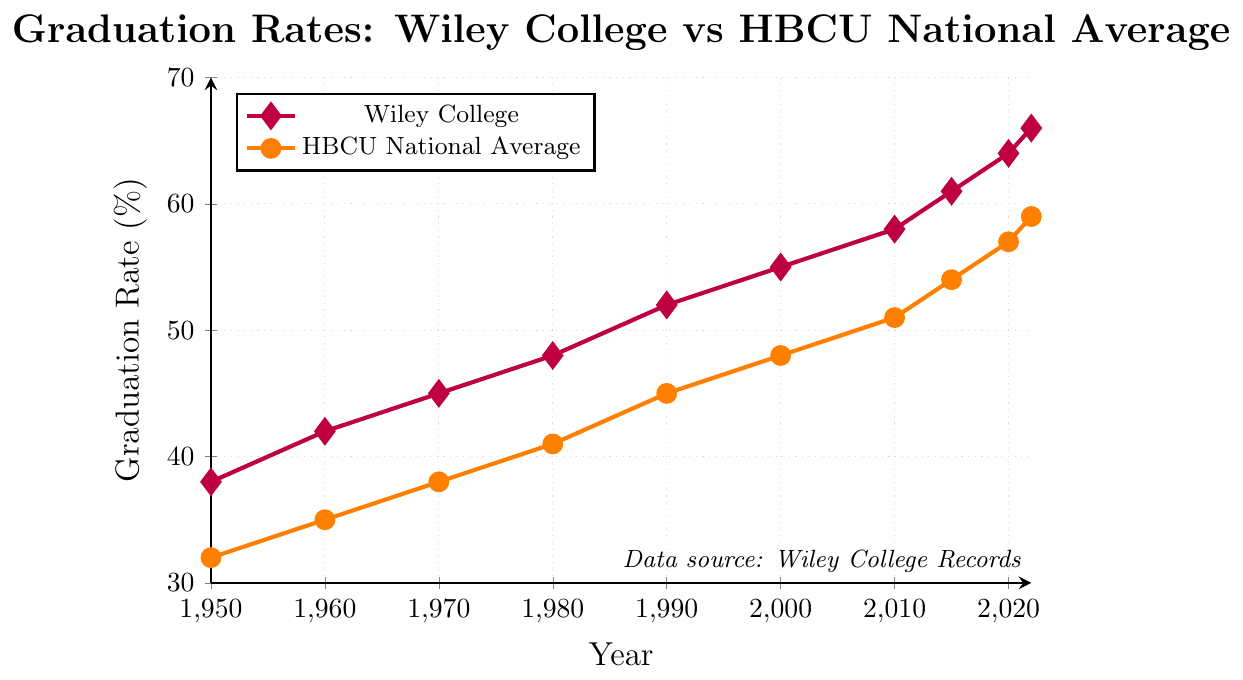What was the graduation rate for Wiley College in 1980? Locate the data point for 1980 on the x-axis and check the corresponding value on the y-axis for the purple line representing Wiley College.
Answer: 48% How much higher was Wiley College's graduation rate than the HBCU national average in 2022? Subtract the HBCU national average graduation rate in 2022 (59%) from Wiley College's graduation rate in 2022 (66%).
Answer: 7% Between which two decades did Wiley College see the greatest increase in graduation rates? Examine the purple line's slope for each decade:
- 1950-1960: 42-38 = 4
- 1960-1970: 45-42 = 3
- 1970-1980: 48-45 = 3
- 1980-1990: 52-48 = 4
- 1990-2000: 55-52 = 3
- 2000-2010: 58-55 = 3
- 2010-2015: 61-58 = 3
- 2015-2020: 64-61 = 3
- 2020-2022: 66-64 = 2
Note that the first decade 1950-1960 and the decade 1980-1990 both have the highest increase of 4%.
Answer: 1950-1960 and 1980-1990 How does the graduation rate trend for Wiley College compare visually to the HBCU national average from 1950 to 2022? Observe the overall direction of both lines. Both the purple (Wiley College) and orange (HBCU National Average) lines show an upward trend throughout the period from 1950 to 2022.
Answer: Both show an upward trend What is the average graduation rate for Wiley College across the entire period shown? Sum the graduation rates for Wiley College (38, 42, 45, 48, 52, 55, 58, 61, 64, 66) and divide by the number of data points (10). (38+42+45+48+52+55+58+61+64+66) = 529, so 529/10 = 52.9
Answer: 52.9 